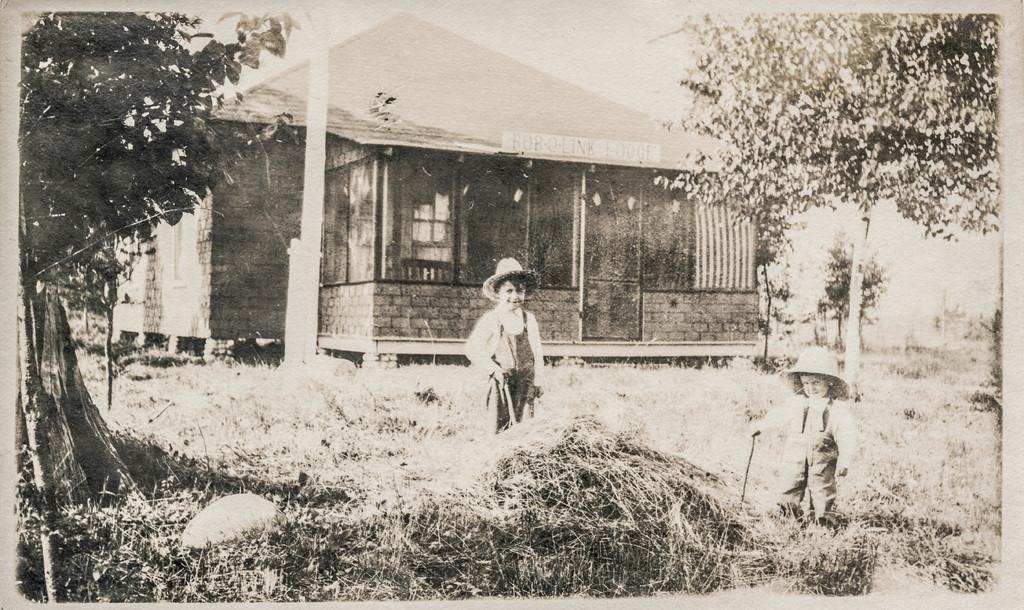Could you give a brief overview of what you see in this image? This is a black and white image. In the center of the image there is a boy. On the right and left side of the image we can see trees. At the bottom of the image we can see grass and kid. In the background we can see pole, house, trees and sky. 